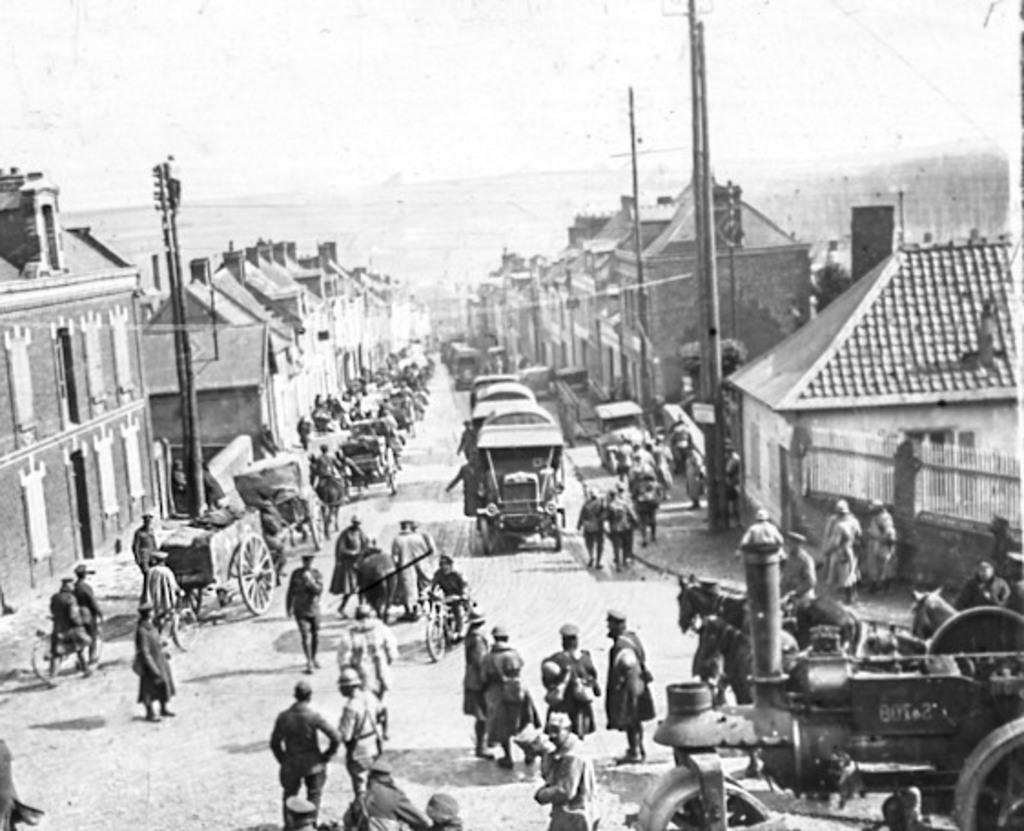What is happening on the road in the image? There are many people standing on the road in the image. What can be seen on both sides of the road? There are buildings on the right and left sides of the image. What structures are present in the image besides buildings? There are poles in the image. What might provide illumination at night in the image? Street lights are present in the image. What is visible at the top of the image? The sky is visible at the top of the image. What type of toothbrush is being used by the person on the left side of the image? There is no toothbrush present in the image; it is a scene of people standing on a road with buildings, poles, and street lights. 